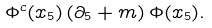Convert formula to latex. <formula><loc_0><loc_0><loc_500><loc_500>\Phi ^ { c } ( x _ { 5 } ) \left ( \partial _ { 5 } + m \right ) \Phi ( x _ { 5 } ) .</formula> 